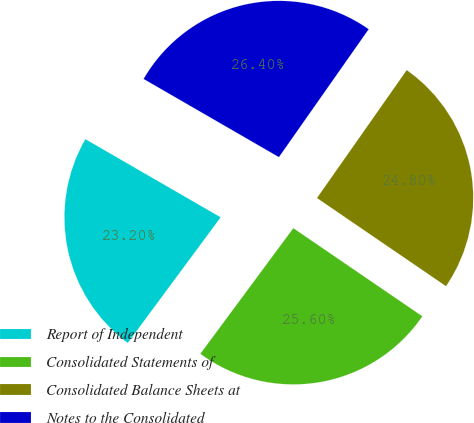Convert chart. <chart><loc_0><loc_0><loc_500><loc_500><pie_chart><fcel>Report of Independent<fcel>Consolidated Statements of<fcel>Consolidated Balance Sheets at<fcel>Notes to the Consolidated<nl><fcel>23.2%<fcel>25.6%<fcel>24.8%<fcel>26.4%<nl></chart> 